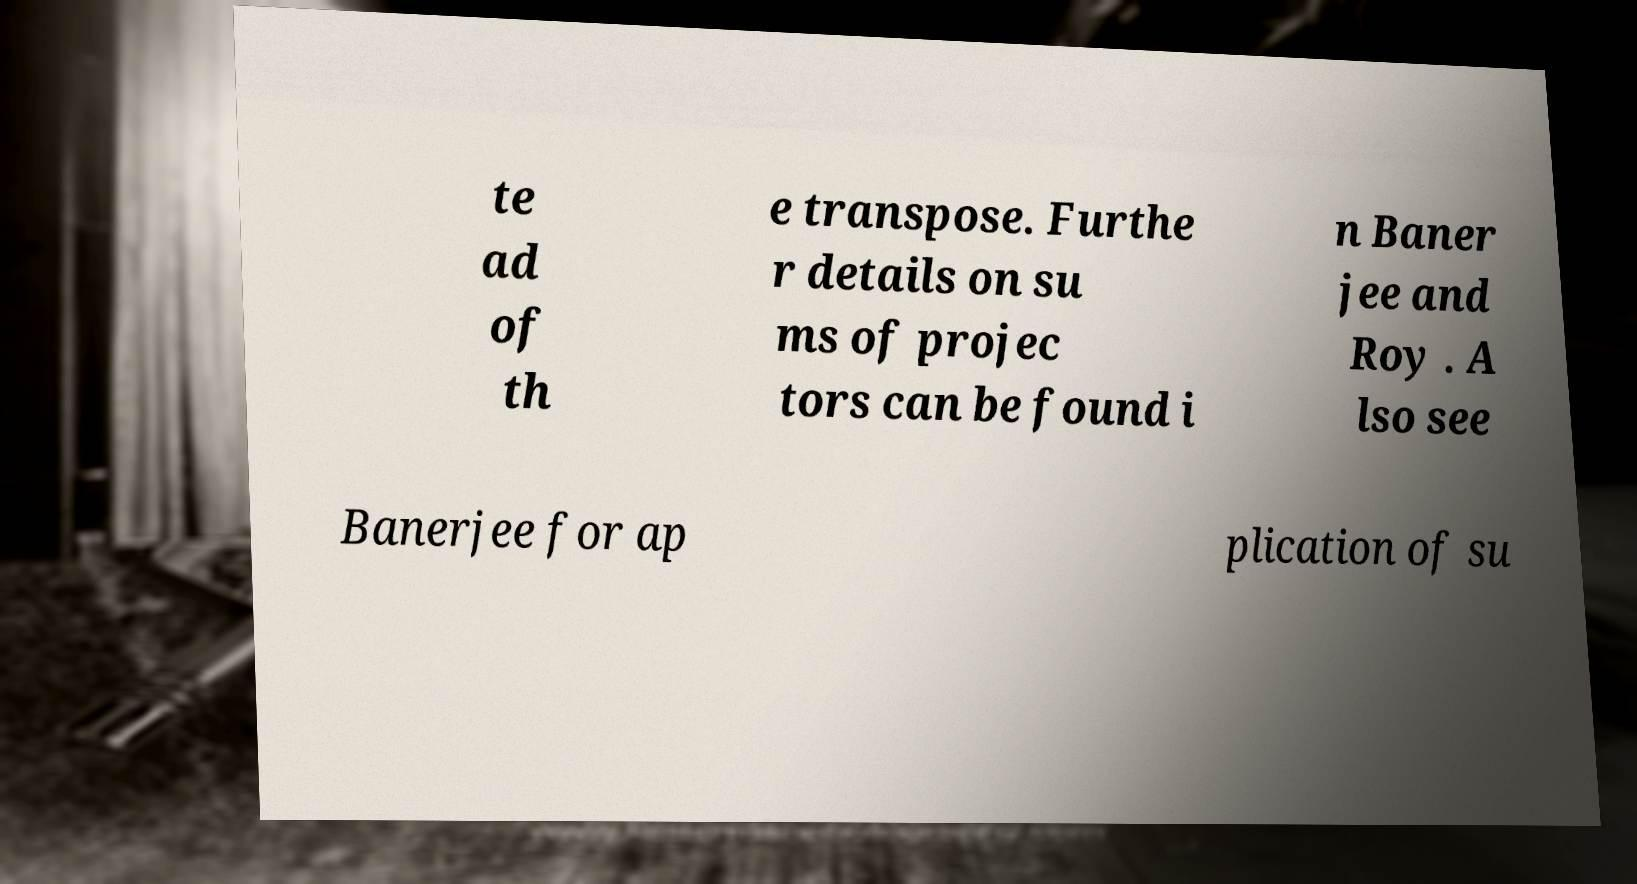Please identify and transcribe the text found in this image. te ad of th e transpose. Furthe r details on su ms of projec tors can be found i n Baner jee and Roy . A lso see Banerjee for ap plication of su 